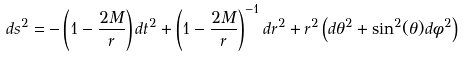<formula> <loc_0><loc_0><loc_500><loc_500>d s ^ { 2 } = - \left ( 1 - \frac { 2 M } { r } \right ) d t ^ { 2 } + \left ( 1 - \frac { 2 M } { r } \right ) ^ { - 1 } d r ^ { 2 } + r ^ { 2 } \left ( d \theta ^ { 2 } + \sin ^ { 2 } ( \theta ) d \phi ^ { 2 } \right )</formula> 